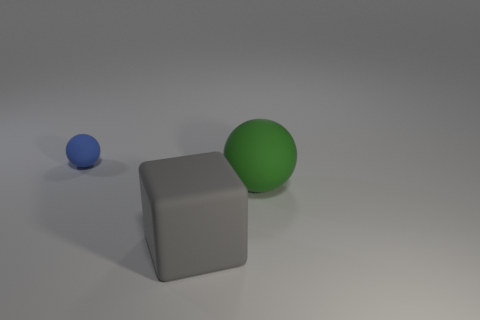There is a object that is in front of the matte ball in front of the object that is behind the large green rubber object; what is its color?
Keep it short and to the point. Gray. There is a matte cube that is the same size as the green rubber object; what is its color?
Offer a very short reply. Gray. How many rubber objects are either blue blocks or balls?
Offer a terse response. 2. There is a ball that is the same material as the small blue thing; what color is it?
Make the answer very short. Green. What is the ball to the left of the big object on the left side of the green sphere made of?
Provide a short and direct response. Rubber. What number of objects are either rubber objects right of the tiny rubber thing or rubber spheres that are to the right of the blue matte sphere?
Provide a short and direct response. 2. There is a rubber ball that is to the right of the sphere that is left of the rubber ball that is in front of the small sphere; what is its size?
Ensure brevity in your answer.  Large. Are there the same number of gray rubber things that are to the right of the big gray matte object and gray metallic spheres?
Keep it short and to the point. Yes. Is there anything else that is the same shape as the gray thing?
Provide a short and direct response. No. There is a big green matte object; is it the same shape as the rubber thing that is behind the green matte ball?
Provide a short and direct response. Yes. 